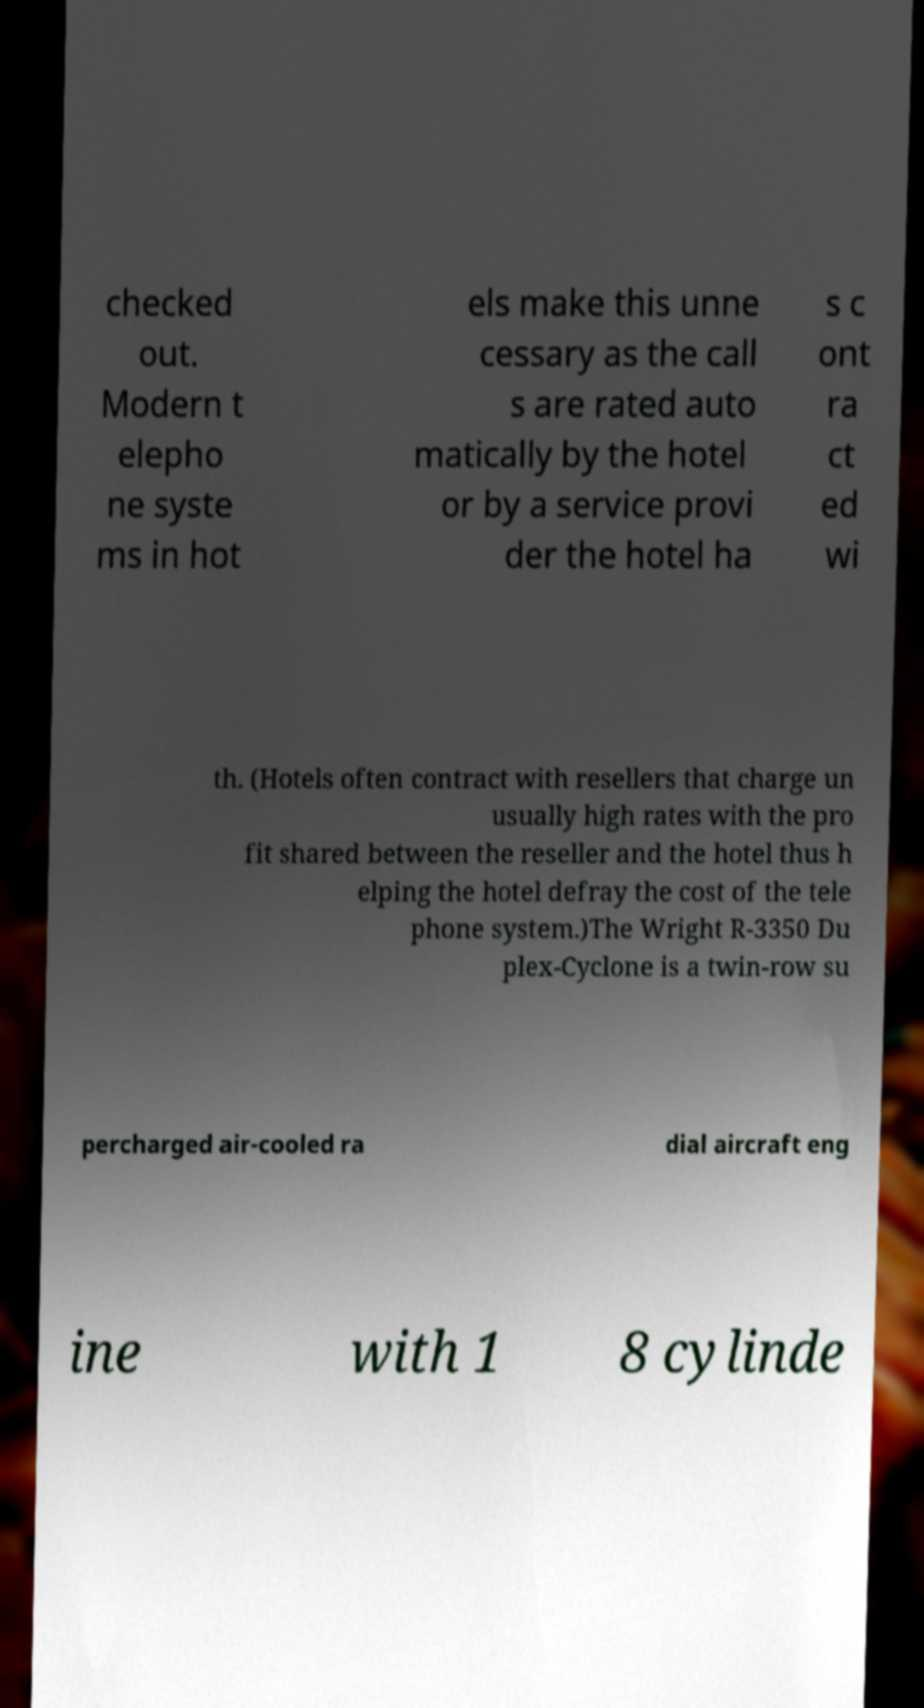For documentation purposes, I need the text within this image transcribed. Could you provide that? checked out. Modern t elepho ne syste ms in hot els make this unne cessary as the call s are rated auto matically by the hotel or by a service provi der the hotel ha s c ont ra ct ed wi th. (Hotels often contract with resellers that charge un usually high rates with the pro fit shared between the reseller and the hotel thus h elping the hotel defray the cost of the tele phone system.)The Wright R-3350 Du plex-Cyclone is a twin-row su percharged air-cooled ra dial aircraft eng ine with 1 8 cylinde 